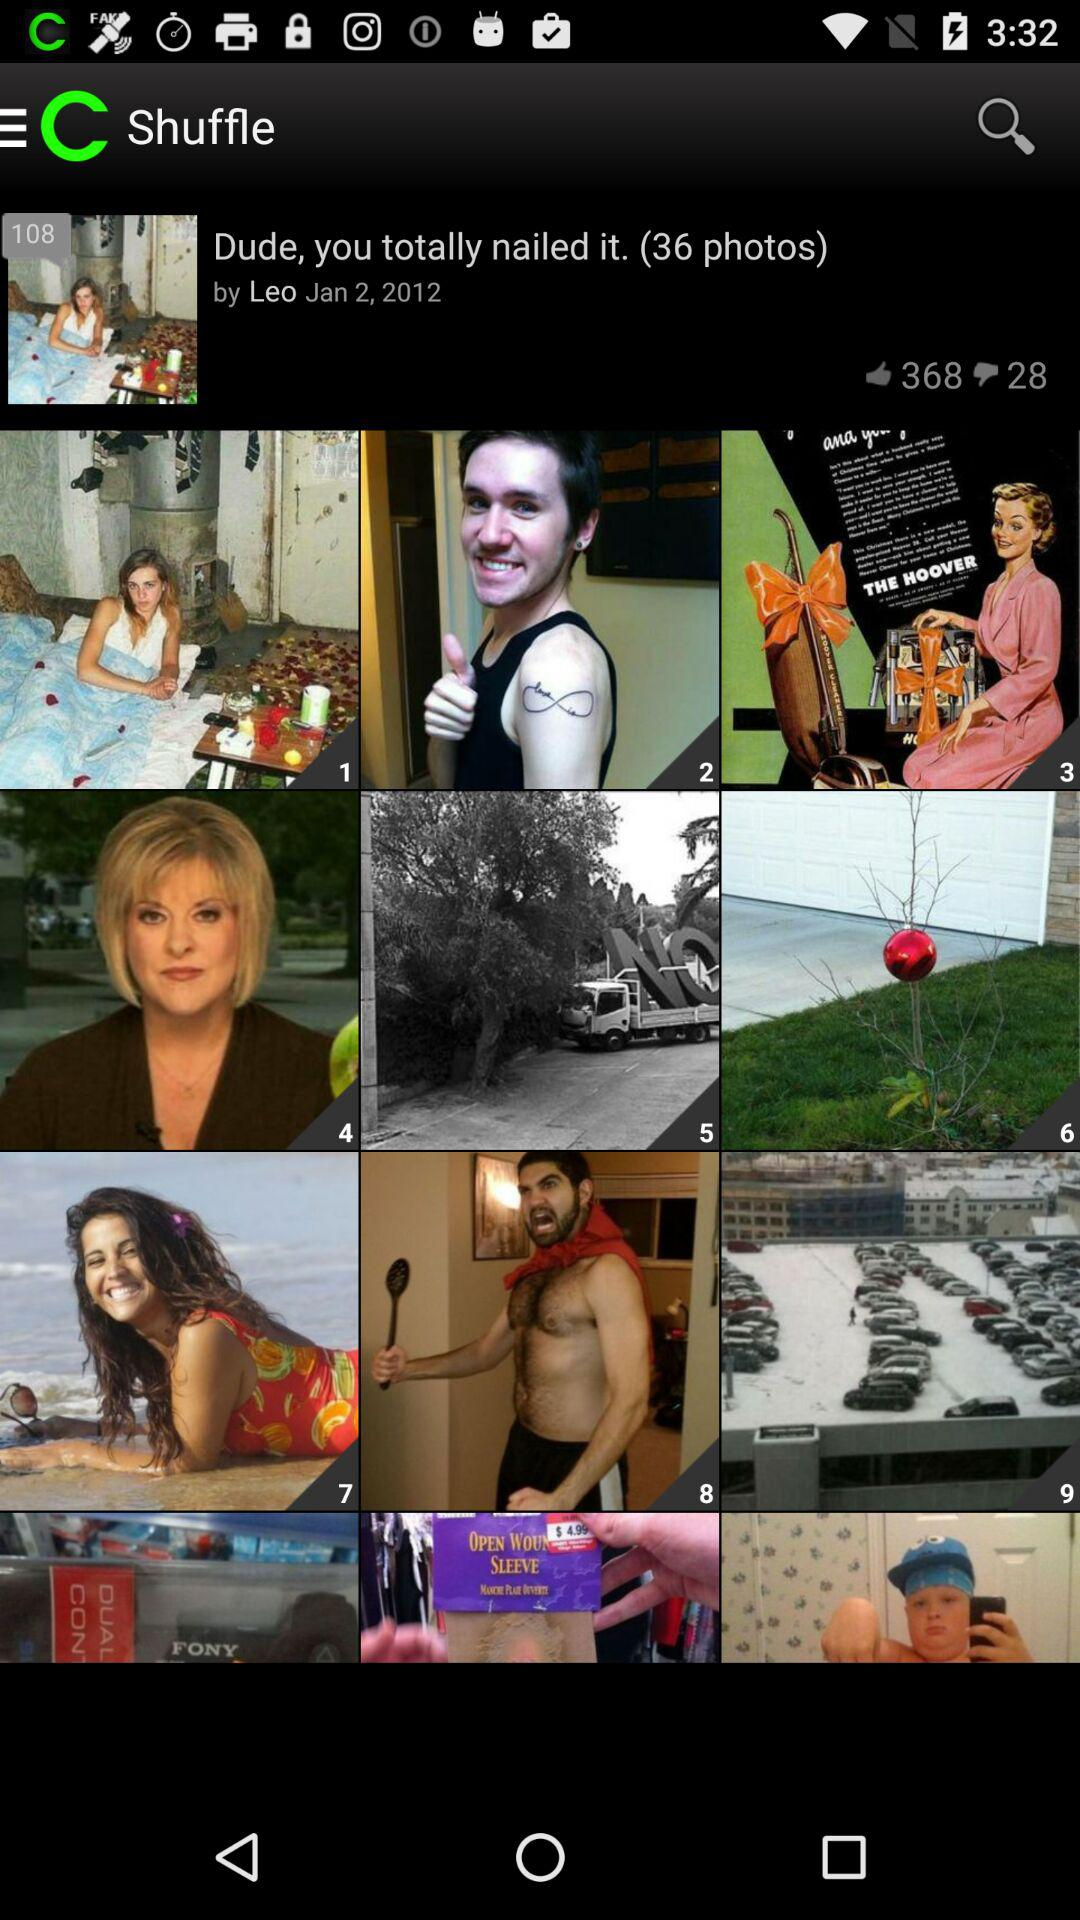What is the number of dislikes? The number of dislikes is 28. 